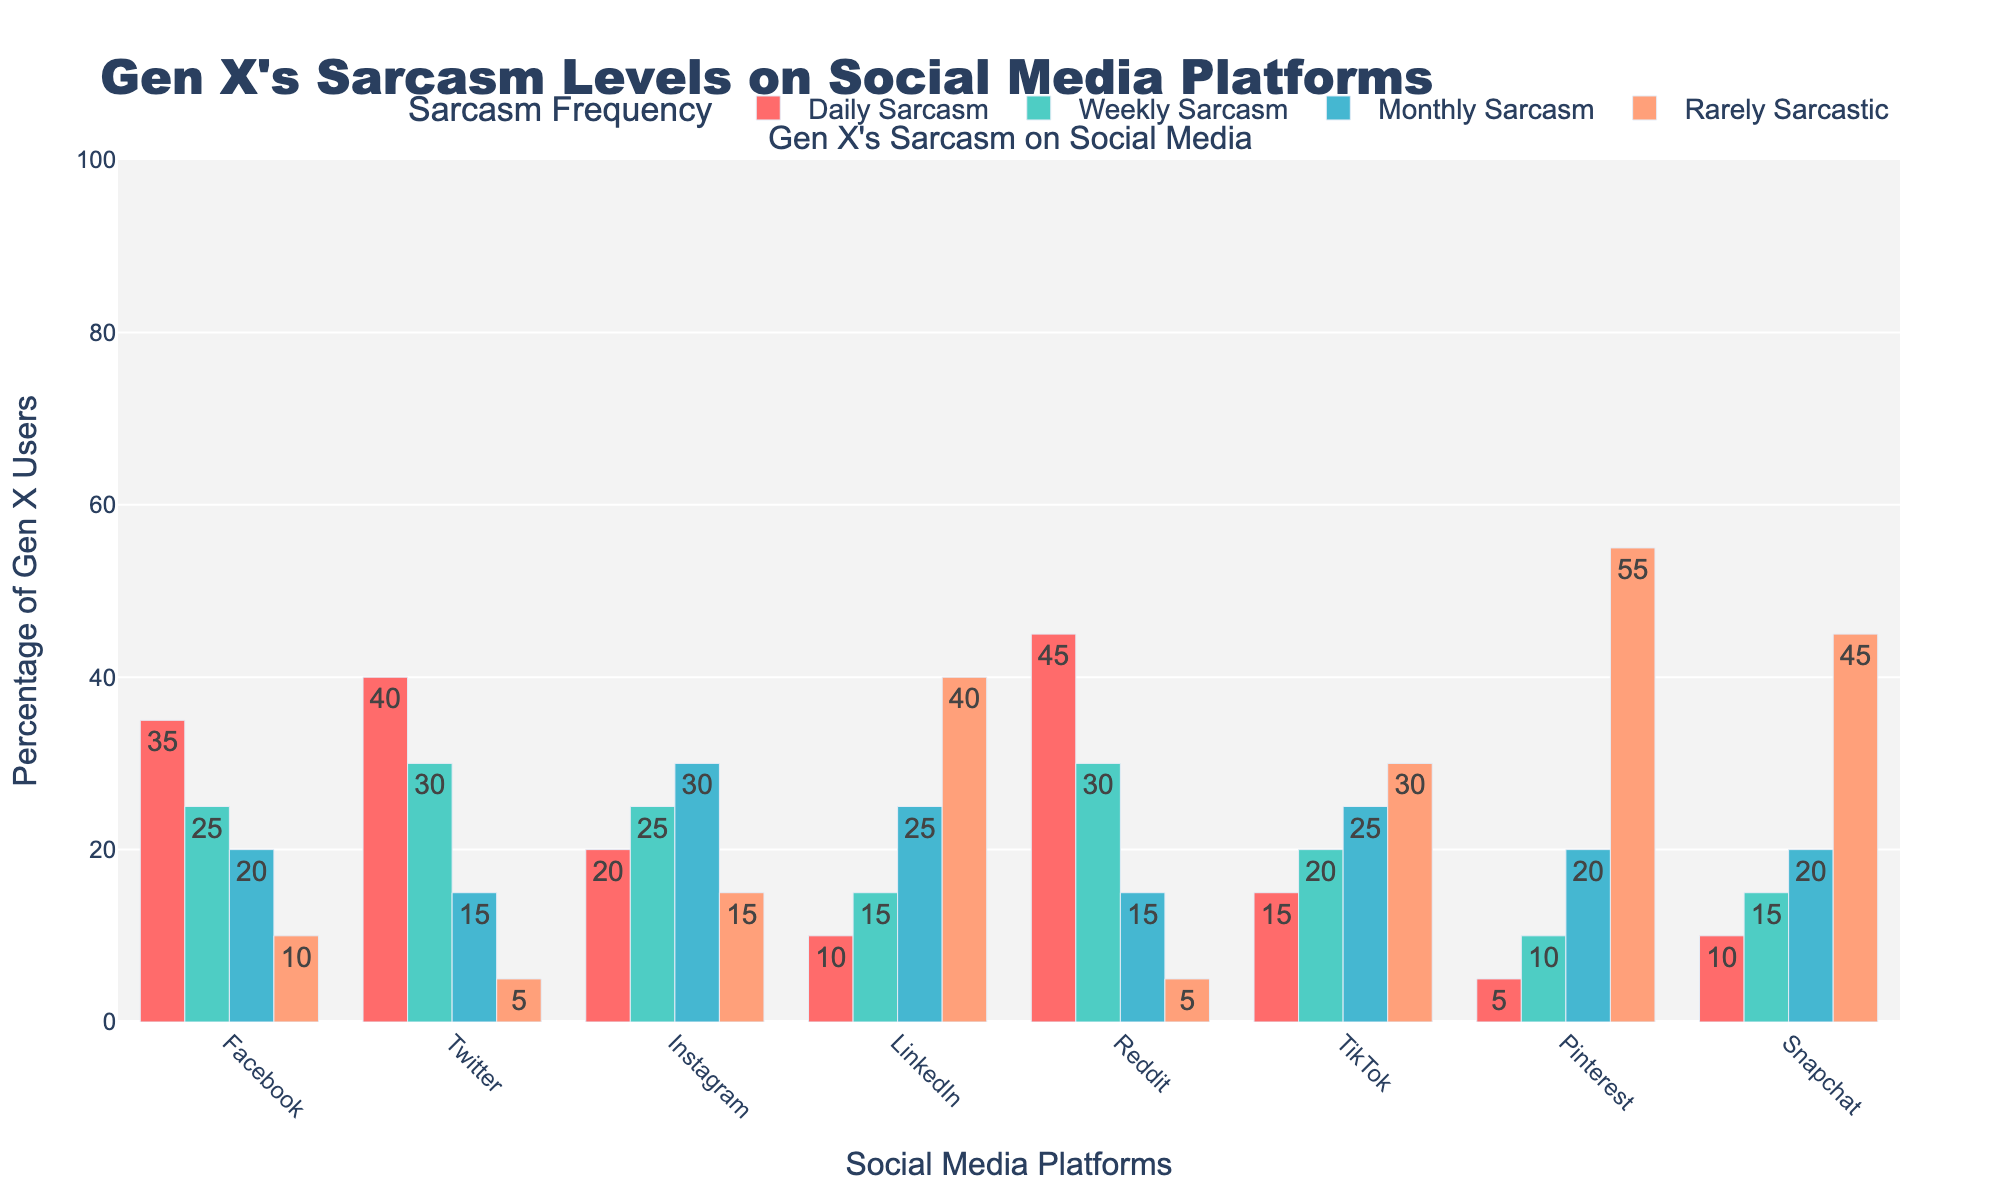Which platform has the highest percentage of daily sarcastic posts? Look for the tallest bar in the "Daily Sarcasm" category. The tallest bar belongs to Reddit.
Answer: Reddit Which platform has a lower percentage of weekly sarcastic posts compared to Facebook? Compare the "Weekly Sarcasm" bars for all platforms against Facebook's. Facebook has 25%, and platforms with lower values are Instagram, LinkedIn, TikTok, Pinterest, and Snapchat.
Answer: Instagram, LinkedIn, TikTok, Pinterest, Snapchat What's the total percentage of Gen X'ers who post sarcastic content daily across all platforms? Sum up the "Daily Sarcasm" percentages: 35 (Facebook) + 40 (Twitter) + 20 (Instagram) + 10 (LinkedIn) + 45 (Reddit) + 15 (TikTok) + 5 (Pinterest) + 10 (Snapchat) = 180.
Answer: 180 Which platform has the highest percentage of rarely sarcastic posts? Look for the tallest bar in the "Rarely Sarcastic" category. The tallest bar belongs to Pinterest.
Answer: Pinterest Between Twitter and Facebook, which platform has a higher average percentage of sarcastic posts across all frequencies? Calculate the average for both platforms. For Twitter: (40 + 30 + 15 + 5)/4 = 22.5. For Facebook: (35 + 25 + 20 + 10)/4 = 22.5. Both have the same average.
Answer: Tie (22.5) Which platform shows more varied sarcasm usage across frequencies, Twitter or Instagram? Compute the range (difference between highest and lowest values) for both. Twitter: 40 (Daily) - 5 (Rarely) = 35. Instagram: 30 (Monthly) - 15 (Rarely) = 15. Twitter has a wider range, indicating more varied usage.
Answer: Twitter Which sarcastic frequency category is most commonly used on Reddit? Determine which sarcastic frequency bar is tallest for Reddit. The "Daily Sarcasm" bar is tallest for Reddit with 45%.
Answer: Daily Sarcasm What's the difference in the percentage of daily sarcastic posts between the platform with the most and the platform with the least amount? The platform with the most is Reddit with 45%, and the platform with the least is Pinterest with 5%. The difference is 45 - 5 = 40.
Answer: 40 Which platform's users are least likely to use sarcasm on a monthly basis? Look for the shortest "Monthly Sarcasm" bar. The shortest bar is for Reddit, at 15%.
Answer: Reddit 